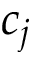<formula> <loc_0><loc_0><loc_500><loc_500>c _ { j }</formula> 